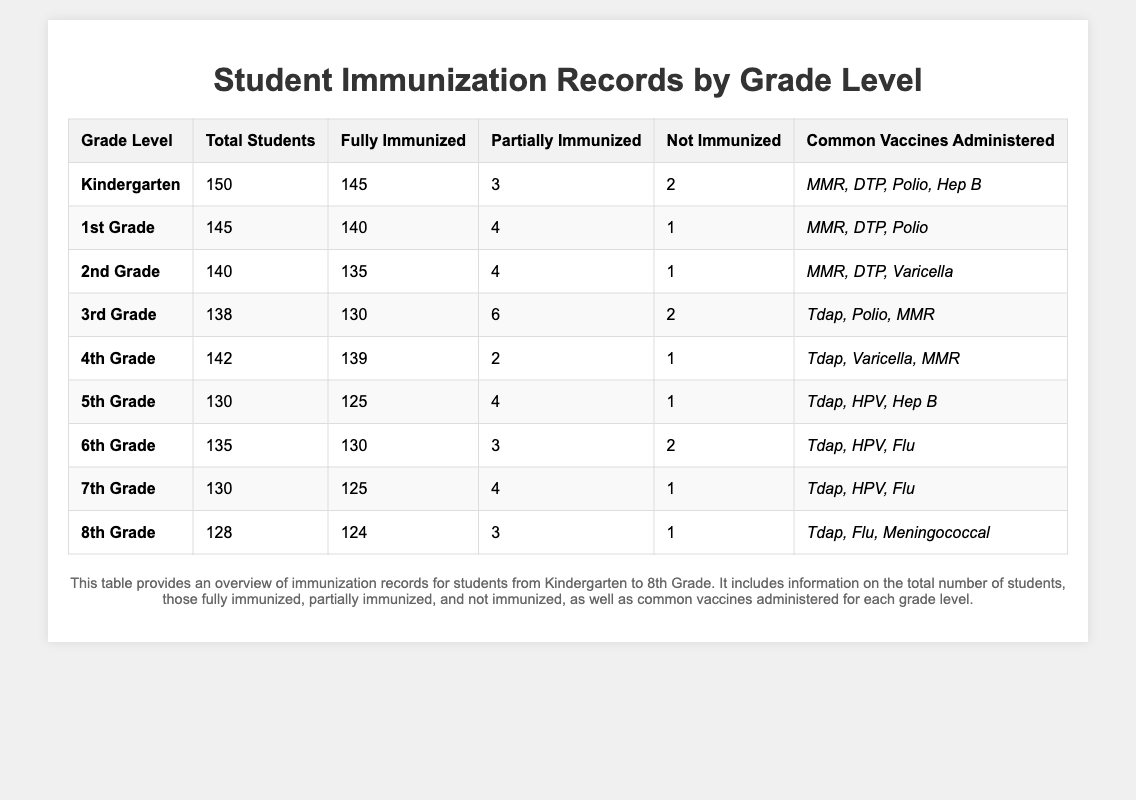What is the total number of students in 2nd Grade? According to the table, the total number of students in 2nd Grade is explicitly stated in the "Total Students" column. The value is 140.
Answer: 140 How many students in 6th Grade are not immunized? From the table, the "Not Immunized" column for 6th Grade shows a value of 2.
Answer: 2 Which grade level has the highest number of fully immunized students? By comparing the "Fully Immunized" column across all grade levels, Kindergarten has the highest number with 145 fully immunized students.
Answer: Kindergarten Is the percentage of fully immunized students in 5th Grade greater than 95%? To find this, we calculate the percentage: (125 fully immunized / 130 total students) * 100 = 96.15%, which is greater than 95%.
Answer: Yes How many students across all grades are fully immunized? We can sum the "Fully Immunized" values from each grade: 145 + 140 + 135 + 130 + 139 + 130 + 125 + 124 = 1,068.
Answer: 1,068 Which grade has the least number of students who are not immunized? Reviewing the "Not Immunized" column, 1st Grade, 2nd Grade, 4th Grade, 5th Grade, 7th Grade, and 8th Grade each have 1 student not immunized. However, Kindergarten and 3rd Grade have 2 students. Thus, the grades with the least number are 1st, 2nd, 4th, 5th, 7th, and 8th.
Answer: 1st, 2nd, 4th, 5th, 7th, 8th Grades What is the average number of students per grade level across all grades? To find the average, we sum the total number of students (150 + 145 + 140 + 138 + 142 + 130 + 135 + 130 + 128 = 1,158) and divide by the number of grades (9), resulting in 1,158 / 9 = 128.67.
Answer: 128.67 In total, how many students are either partially or not immunized in 3rd Grade? We need to add the "Partially Immunized" and "Not Immunized" values for 3rd Grade: 6 (partially) + 2 (not) = 8.
Answer: 8 Do all grade levels administer the same common vaccines? By comparing the "Common Vaccines Administered" column, we find that different grades have varying vaccines listed, indicating they do not all administer the same vaccines.
Answer: No What percentage of 4th Grade students are partially immunized? To calculate: (2 partially immunized / 142 total students) * 100 = 1.41%.
Answer: 1.41% 